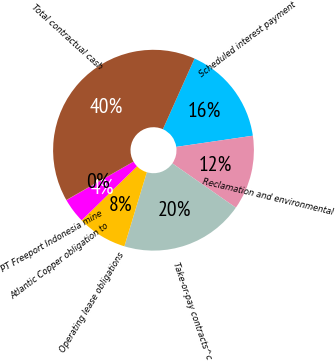<chart> <loc_0><loc_0><loc_500><loc_500><pie_chart><fcel>Scheduled interest payment<fcel>Reclamation and environmental<fcel>Take-or-pay contracts^c<fcel>Operating lease obligations<fcel>Atlantic Copper obligation to<fcel>PT Freeport Indonesia mine<fcel>Total contractual cash<nl><fcel>16.0%<fcel>12.0%<fcel>19.99%<fcel>8.01%<fcel>4.02%<fcel>0.03%<fcel>39.95%<nl></chart> 